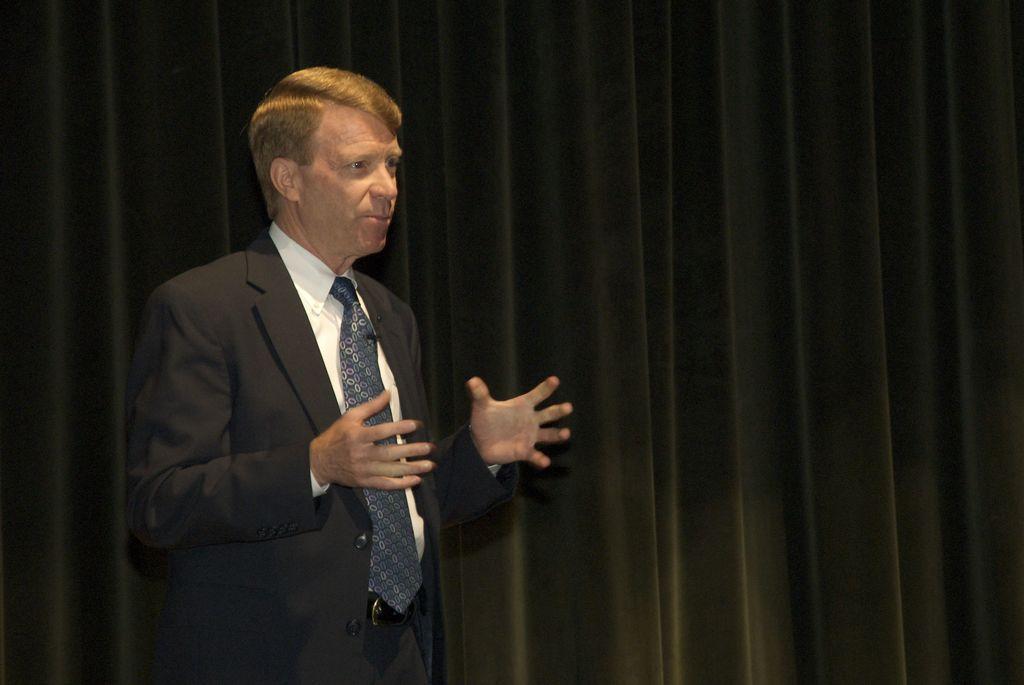Could you give a brief overview of what you see in this image? This person wore a black suit and tie. Background there is a black curtain. 